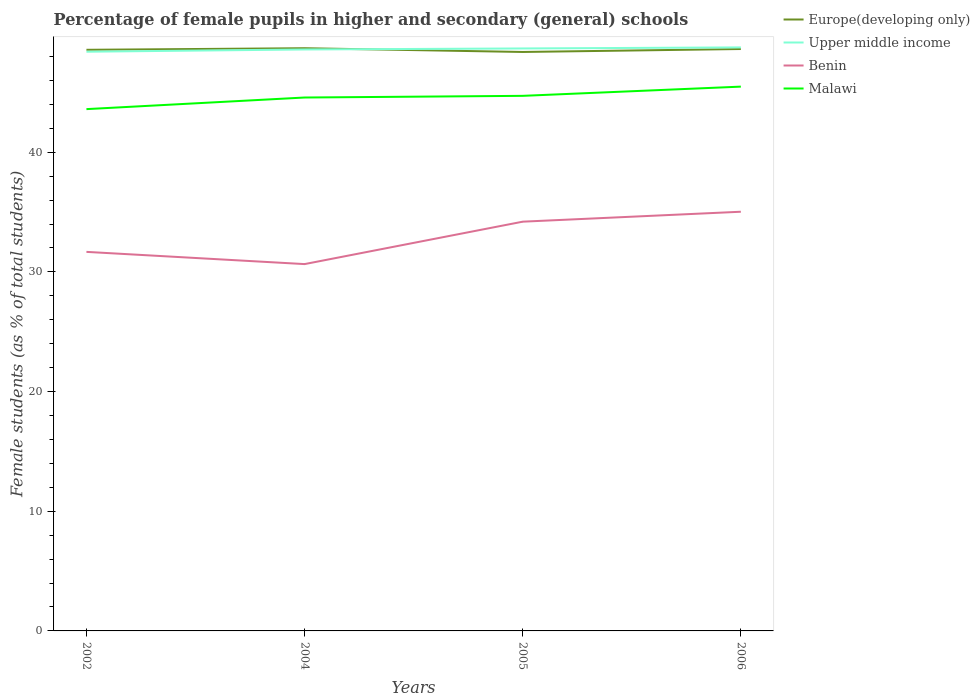How many different coloured lines are there?
Your answer should be very brief. 4. Does the line corresponding to Benin intersect with the line corresponding to Malawi?
Ensure brevity in your answer.  No. Across all years, what is the maximum percentage of female pupils in higher and secondary schools in Upper middle income?
Ensure brevity in your answer.  48.4. What is the total percentage of female pupils in higher and secondary schools in Benin in the graph?
Your response must be concise. 1.02. What is the difference between the highest and the second highest percentage of female pupils in higher and secondary schools in Europe(developing only)?
Make the answer very short. 0.31. What is the difference between two consecutive major ticks on the Y-axis?
Your response must be concise. 10. Does the graph contain any zero values?
Make the answer very short. No. Does the graph contain grids?
Give a very brief answer. No. Where does the legend appear in the graph?
Make the answer very short. Top right. How many legend labels are there?
Provide a short and direct response. 4. What is the title of the graph?
Offer a terse response. Percentage of female pupils in higher and secondary (general) schools. What is the label or title of the X-axis?
Your response must be concise. Years. What is the label or title of the Y-axis?
Your response must be concise. Female students (as % of total students). What is the Female students (as % of total students) in Europe(developing only) in 2002?
Your answer should be compact. 48.56. What is the Female students (as % of total students) of Upper middle income in 2002?
Your answer should be very brief. 48.4. What is the Female students (as % of total students) of Benin in 2002?
Your answer should be very brief. 31.67. What is the Female students (as % of total students) in Malawi in 2002?
Offer a terse response. 43.6. What is the Female students (as % of total students) in Europe(developing only) in 2004?
Offer a very short reply. 48.69. What is the Female students (as % of total students) in Upper middle income in 2004?
Provide a succinct answer. 48.59. What is the Female students (as % of total students) in Benin in 2004?
Ensure brevity in your answer.  30.65. What is the Female students (as % of total students) in Malawi in 2004?
Keep it short and to the point. 44.57. What is the Female students (as % of total students) of Europe(developing only) in 2005?
Your response must be concise. 48.38. What is the Female students (as % of total students) of Upper middle income in 2005?
Make the answer very short. 48.67. What is the Female students (as % of total students) in Benin in 2005?
Make the answer very short. 34.2. What is the Female students (as % of total students) of Malawi in 2005?
Provide a succinct answer. 44.71. What is the Female students (as % of total students) in Europe(developing only) in 2006?
Offer a terse response. 48.63. What is the Female students (as % of total students) of Upper middle income in 2006?
Give a very brief answer. 48.76. What is the Female students (as % of total students) in Benin in 2006?
Provide a short and direct response. 35.03. What is the Female students (as % of total students) of Malawi in 2006?
Offer a very short reply. 45.48. Across all years, what is the maximum Female students (as % of total students) of Europe(developing only)?
Provide a short and direct response. 48.69. Across all years, what is the maximum Female students (as % of total students) of Upper middle income?
Your response must be concise. 48.76. Across all years, what is the maximum Female students (as % of total students) in Benin?
Your answer should be very brief. 35.03. Across all years, what is the maximum Female students (as % of total students) in Malawi?
Your response must be concise. 45.48. Across all years, what is the minimum Female students (as % of total students) in Europe(developing only)?
Offer a very short reply. 48.38. Across all years, what is the minimum Female students (as % of total students) of Upper middle income?
Your answer should be very brief. 48.4. Across all years, what is the minimum Female students (as % of total students) in Benin?
Your answer should be compact. 30.65. Across all years, what is the minimum Female students (as % of total students) of Malawi?
Offer a very short reply. 43.6. What is the total Female students (as % of total students) in Europe(developing only) in the graph?
Provide a succinct answer. 194.26. What is the total Female students (as % of total students) of Upper middle income in the graph?
Your response must be concise. 194.42. What is the total Female students (as % of total students) in Benin in the graph?
Provide a short and direct response. 131.55. What is the total Female students (as % of total students) in Malawi in the graph?
Offer a terse response. 178.37. What is the difference between the Female students (as % of total students) in Europe(developing only) in 2002 and that in 2004?
Offer a very short reply. -0.13. What is the difference between the Female students (as % of total students) of Upper middle income in 2002 and that in 2004?
Your response must be concise. -0.19. What is the difference between the Female students (as % of total students) of Benin in 2002 and that in 2004?
Ensure brevity in your answer.  1.02. What is the difference between the Female students (as % of total students) in Malawi in 2002 and that in 2004?
Your answer should be compact. -0.97. What is the difference between the Female students (as % of total students) of Europe(developing only) in 2002 and that in 2005?
Make the answer very short. 0.18. What is the difference between the Female students (as % of total students) of Upper middle income in 2002 and that in 2005?
Provide a succinct answer. -0.27. What is the difference between the Female students (as % of total students) in Benin in 2002 and that in 2005?
Your response must be concise. -2.52. What is the difference between the Female students (as % of total students) of Malawi in 2002 and that in 2005?
Provide a short and direct response. -1.11. What is the difference between the Female students (as % of total students) of Europe(developing only) in 2002 and that in 2006?
Your answer should be very brief. -0.07. What is the difference between the Female students (as % of total students) of Upper middle income in 2002 and that in 2006?
Provide a succinct answer. -0.36. What is the difference between the Female students (as % of total students) in Benin in 2002 and that in 2006?
Give a very brief answer. -3.35. What is the difference between the Female students (as % of total students) of Malawi in 2002 and that in 2006?
Offer a terse response. -1.88. What is the difference between the Female students (as % of total students) in Europe(developing only) in 2004 and that in 2005?
Your answer should be compact. 0.31. What is the difference between the Female students (as % of total students) in Upper middle income in 2004 and that in 2005?
Give a very brief answer. -0.08. What is the difference between the Female students (as % of total students) in Benin in 2004 and that in 2005?
Offer a very short reply. -3.54. What is the difference between the Female students (as % of total students) of Malawi in 2004 and that in 2005?
Provide a succinct answer. -0.14. What is the difference between the Female students (as % of total students) of Europe(developing only) in 2004 and that in 2006?
Offer a terse response. 0.07. What is the difference between the Female students (as % of total students) of Upper middle income in 2004 and that in 2006?
Provide a short and direct response. -0.17. What is the difference between the Female students (as % of total students) in Benin in 2004 and that in 2006?
Your answer should be compact. -4.38. What is the difference between the Female students (as % of total students) in Malawi in 2004 and that in 2006?
Keep it short and to the point. -0.91. What is the difference between the Female students (as % of total students) of Europe(developing only) in 2005 and that in 2006?
Give a very brief answer. -0.25. What is the difference between the Female students (as % of total students) in Upper middle income in 2005 and that in 2006?
Provide a short and direct response. -0.09. What is the difference between the Female students (as % of total students) of Benin in 2005 and that in 2006?
Give a very brief answer. -0.83. What is the difference between the Female students (as % of total students) of Malawi in 2005 and that in 2006?
Provide a succinct answer. -0.77. What is the difference between the Female students (as % of total students) of Europe(developing only) in 2002 and the Female students (as % of total students) of Upper middle income in 2004?
Keep it short and to the point. -0.03. What is the difference between the Female students (as % of total students) in Europe(developing only) in 2002 and the Female students (as % of total students) in Benin in 2004?
Offer a very short reply. 17.91. What is the difference between the Female students (as % of total students) of Europe(developing only) in 2002 and the Female students (as % of total students) of Malawi in 2004?
Give a very brief answer. 3.99. What is the difference between the Female students (as % of total students) of Upper middle income in 2002 and the Female students (as % of total students) of Benin in 2004?
Your answer should be compact. 17.75. What is the difference between the Female students (as % of total students) in Upper middle income in 2002 and the Female students (as % of total students) in Malawi in 2004?
Provide a succinct answer. 3.83. What is the difference between the Female students (as % of total students) in Benin in 2002 and the Female students (as % of total students) in Malawi in 2004?
Give a very brief answer. -12.9. What is the difference between the Female students (as % of total students) of Europe(developing only) in 2002 and the Female students (as % of total students) of Upper middle income in 2005?
Offer a terse response. -0.11. What is the difference between the Female students (as % of total students) of Europe(developing only) in 2002 and the Female students (as % of total students) of Benin in 2005?
Provide a short and direct response. 14.36. What is the difference between the Female students (as % of total students) in Europe(developing only) in 2002 and the Female students (as % of total students) in Malawi in 2005?
Offer a terse response. 3.85. What is the difference between the Female students (as % of total students) in Upper middle income in 2002 and the Female students (as % of total students) in Benin in 2005?
Provide a short and direct response. 14.2. What is the difference between the Female students (as % of total students) in Upper middle income in 2002 and the Female students (as % of total students) in Malawi in 2005?
Provide a succinct answer. 3.69. What is the difference between the Female students (as % of total students) of Benin in 2002 and the Female students (as % of total students) of Malawi in 2005?
Ensure brevity in your answer.  -13.04. What is the difference between the Female students (as % of total students) in Europe(developing only) in 2002 and the Female students (as % of total students) in Upper middle income in 2006?
Provide a succinct answer. -0.2. What is the difference between the Female students (as % of total students) of Europe(developing only) in 2002 and the Female students (as % of total students) of Benin in 2006?
Your answer should be compact. 13.53. What is the difference between the Female students (as % of total students) in Europe(developing only) in 2002 and the Female students (as % of total students) in Malawi in 2006?
Your answer should be very brief. 3.08. What is the difference between the Female students (as % of total students) in Upper middle income in 2002 and the Female students (as % of total students) in Benin in 2006?
Offer a very short reply. 13.37. What is the difference between the Female students (as % of total students) in Upper middle income in 2002 and the Female students (as % of total students) in Malawi in 2006?
Provide a short and direct response. 2.92. What is the difference between the Female students (as % of total students) of Benin in 2002 and the Female students (as % of total students) of Malawi in 2006?
Offer a very short reply. -13.81. What is the difference between the Female students (as % of total students) of Europe(developing only) in 2004 and the Female students (as % of total students) of Upper middle income in 2005?
Offer a very short reply. 0.02. What is the difference between the Female students (as % of total students) in Europe(developing only) in 2004 and the Female students (as % of total students) in Benin in 2005?
Your answer should be compact. 14.49. What is the difference between the Female students (as % of total students) of Europe(developing only) in 2004 and the Female students (as % of total students) of Malawi in 2005?
Provide a succinct answer. 3.98. What is the difference between the Female students (as % of total students) of Upper middle income in 2004 and the Female students (as % of total students) of Benin in 2005?
Offer a terse response. 14.39. What is the difference between the Female students (as % of total students) of Upper middle income in 2004 and the Female students (as % of total students) of Malawi in 2005?
Your answer should be very brief. 3.88. What is the difference between the Female students (as % of total students) of Benin in 2004 and the Female students (as % of total students) of Malawi in 2005?
Provide a short and direct response. -14.06. What is the difference between the Female students (as % of total students) in Europe(developing only) in 2004 and the Female students (as % of total students) in Upper middle income in 2006?
Your response must be concise. -0.07. What is the difference between the Female students (as % of total students) in Europe(developing only) in 2004 and the Female students (as % of total students) in Benin in 2006?
Offer a very short reply. 13.66. What is the difference between the Female students (as % of total students) in Europe(developing only) in 2004 and the Female students (as % of total students) in Malawi in 2006?
Your answer should be very brief. 3.21. What is the difference between the Female students (as % of total students) in Upper middle income in 2004 and the Female students (as % of total students) in Benin in 2006?
Ensure brevity in your answer.  13.56. What is the difference between the Female students (as % of total students) in Upper middle income in 2004 and the Female students (as % of total students) in Malawi in 2006?
Give a very brief answer. 3.11. What is the difference between the Female students (as % of total students) in Benin in 2004 and the Female students (as % of total students) in Malawi in 2006?
Offer a very short reply. -14.83. What is the difference between the Female students (as % of total students) of Europe(developing only) in 2005 and the Female students (as % of total students) of Upper middle income in 2006?
Ensure brevity in your answer.  -0.38. What is the difference between the Female students (as % of total students) in Europe(developing only) in 2005 and the Female students (as % of total students) in Benin in 2006?
Provide a short and direct response. 13.35. What is the difference between the Female students (as % of total students) of Europe(developing only) in 2005 and the Female students (as % of total students) of Malawi in 2006?
Make the answer very short. 2.9. What is the difference between the Female students (as % of total students) in Upper middle income in 2005 and the Female students (as % of total students) in Benin in 2006?
Offer a terse response. 13.64. What is the difference between the Female students (as % of total students) of Upper middle income in 2005 and the Female students (as % of total students) of Malawi in 2006?
Offer a terse response. 3.19. What is the difference between the Female students (as % of total students) in Benin in 2005 and the Female students (as % of total students) in Malawi in 2006?
Your answer should be compact. -11.29. What is the average Female students (as % of total students) in Europe(developing only) per year?
Keep it short and to the point. 48.56. What is the average Female students (as % of total students) in Upper middle income per year?
Your answer should be very brief. 48.61. What is the average Female students (as % of total students) of Benin per year?
Your answer should be very brief. 32.89. What is the average Female students (as % of total students) in Malawi per year?
Provide a short and direct response. 44.59. In the year 2002, what is the difference between the Female students (as % of total students) of Europe(developing only) and Female students (as % of total students) of Upper middle income?
Your response must be concise. 0.16. In the year 2002, what is the difference between the Female students (as % of total students) in Europe(developing only) and Female students (as % of total students) in Benin?
Keep it short and to the point. 16.89. In the year 2002, what is the difference between the Female students (as % of total students) in Europe(developing only) and Female students (as % of total students) in Malawi?
Keep it short and to the point. 4.96. In the year 2002, what is the difference between the Female students (as % of total students) of Upper middle income and Female students (as % of total students) of Benin?
Give a very brief answer. 16.73. In the year 2002, what is the difference between the Female students (as % of total students) of Upper middle income and Female students (as % of total students) of Malawi?
Your response must be concise. 4.8. In the year 2002, what is the difference between the Female students (as % of total students) in Benin and Female students (as % of total students) in Malawi?
Your answer should be very brief. -11.93. In the year 2004, what is the difference between the Female students (as % of total students) in Europe(developing only) and Female students (as % of total students) in Upper middle income?
Offer a very short reply. 0.1. In the year 2004, what is the difference between the Female students (as % of total students) of Europe(developing only) and Female students (as % of total students) of Benin?
Make the answer very short. 18.04. In the year 2004, what is the difference between the Female students (as % of total students) of Europe(developing only) and Female students (as % of total students) of Malawi?
Your response must be concise. 4.12. In the year 2004, what is the difference between the Female students (as % of total students) of Upper middle income and Female students (as % of total students) of Benin?
Make the answer very short. 17.94. In the year 2004, what is the difference between the Female students (as % of total students) of Upper middle income and Female students (as % of total students) of Malawi?
Give a very brief answer. 4.02. In the year 2004, what is the difference between the Female students (as % of total students) of Benin and Female students (as % of total students) of Malawi?
Keep it short and to the point. -13.92. In the year 2005, what is the difference between the Female students (as % of total students) of Europe(developing only) and Female students (as % of total students) of Upper middle income?
Provide a succinct answer. -0.29. In the year 2005, what is the difference between the Female students (as % of total students) of Europe(developing only) and Female students (as % of total students) of Benin?
Ensure brevity in your answer.  14.18. In the year 2005, what is the difference between the Female students (as % of total students) of Europe(developing only) and Female students (as % of total students) of Malawi?
Your response must be concise. 3.67. In the year 2005, what is the difference between the Female students (as % of total students) in Upper middle income and Female students (as % of total students) in Benin?
Ensure brevity in your answer.  14.48. In the year 2005, what is the difference between the Female students (as % of total students) in Upper middle income and Female students (as % of total students) in Malawi?
Give a very brief answer. 3.96. In the year 2005, what is the difference between the Female students (as % of total students) in Benin and Female students (as % of total students) in Malawi?
Keep it short and to the point. -10.52. In the year 2006, what is the difference between the Female students (as % of total students) of Europe(developing only) and Female students (as % of total students) of Upper middle income?
Ensure brevity in your answer.  -0.13. In the year 2006, what is the difference between the Female students (as % of total students) in Europe(developing only) and Female students (as % of total students) in Benin?
Give a very brief answer. 13.6. In the year 2006, what is the difference between the Female students (as % of total students) of Europe(developing only) and Female students (as % of total students) of Malawi?
Your answer should be very brief. 3.14. In the year 2006, what is the difference between the Female students (as % of total students) of Upper middle income and Female students (as % of total students) of Benin?
Your response must be concise. 13.73. In the year 2006, what is the difference between the Female students (as % of total students) of Upper middle income and Female students (as % of total students) of Malawi?
Provide a succinct answer. 3.28. In the year 2006, what is the difference between the Female students (as % of total students) in Benin and Female students (as % of total students) in Malawi?
Ensure brevity in your answer.  -10.45. What is the ratio of the Female students (as % of total students) in Malawi in 2002 to that in 2004?
Make the answer very short. 0.98. What is the ratio of the Female students (as % of total students) in Upper middle income in 2002 to that in 2005?
Provide a succinct answer. 0.99. What is the ratio of the Female students (as % of total students) in Benin in 2002 to that in 2005?
Make the answer very short. 0.93. What is the ratio of the Female students (as % of total students) of Malawi in 2002 to that in 2005?
Offer a terse response. 0.98. What is the ratio of the Female students (as % of total students) of Europe(developing only) in 2002 to that in 2006?
Give a very brief answer. 1. What is the ratio of the Female students (as % of total students) in Upper middle income in 2002 to that in 2006?
Ensure brevity in your answer.  0.99. What is the ratio of the Female students (as % of total students) in Benin in 2002 to that in 2006?
Make the answer very short. 0.9. What is the ratio of the Female students (as % of total students) of Malawi in 2002 to that in 2006?
Make the answer very short. 0.96. What is the ratio of the Female students (as % of total students) in Europe(developing only) in 2004 to that in 2005?
Your answer should be compact. 1.01. What is the ratio of the Female students (as % of total students) in Upper middle income in 2004 to that in 2005?
Your response must be concise. 1. What is the ratio of the Female students (as % of total students) of Benin in 2004 to that in 2005?
Your response must be concise. 0.9. What is the ratio of the Female students (as % of total students) in Europe(developing only) in 2004 to that in 2006?
Offer a very short reply. 1. What is the ratio of the Female students (as % of total students) of Benin in 2004 to that in 2006?
Provide a succinct answer. 0.88. What is the ratio of the Female students (as % of total students) in Malawi in 2004 to that in 2006?
Offer a very short reply. 0.98. What is the ratio of the Female students (as % of total students) in Upper middle income in 2005 to that in 2006?
Make the answer very short. 1. What is the ratio of the Female students (as % of total students) in Benin in 2005 to that in 2006?
Your answer should be compact. 0.98. What is the ratio of the Female students (as % of total students) in Malawi in 2005 to that in 2006?
Your answer should be compact. 0.98. What is the difference between the highest and the second highest Female students (as % of total students) of Europe(developing only)?
Your answer should be compact. 0.07. What is the difference between the highest and the second highest Female students (as % of total students) in Upper middle income?
Your response must be concise. 0.09. What is the difference between the highest and the second highest Female students (as % of total students) of Benin?
Your response must be concise. 0.83. What is the difference between the highest and the second highest Female students (as % of total students) in Malawi?
Ensure brevity in your answer.  0.77. What is the difference between the highest and the lowest Female students (as % of total students) in Europe(developing only)?
Your response must be concise. 0.31. What is the difference between the highest and the lowest Female students (as % of total students) in Upper middle income?
Keep it short and to the point. 0.36. What is the difference between the highest and the lowest Female students (as % of total students) in Benin?
Provide a succinct answer. 4.38. What is the difference between the highest and the lowest Female students (as % of total students) in Malawi?
Keep it short and to the point. 1.88. 